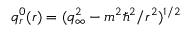Convert formula to latex. <formula><loc_0><loc_0><loc_500><loc_500>q _ { r } ^ { 0 } ( r ) = ( q _ { \infty } ^ { 2 } - m ^ { 2 } \hbar { ^ } { 2 } / r ^ { 2 } ) ^ { 1 / 2 }</formula> 